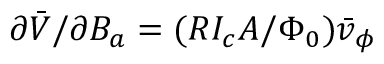Convert formula to latex. <formula><loc_0><loc_0><loc_500><loc_500>\partial \bar { V } / \partial B _ { a } = ( R I _ { c } A / \Phi _ { 0 } ) \bar { v } _ { \phi }</formula> 